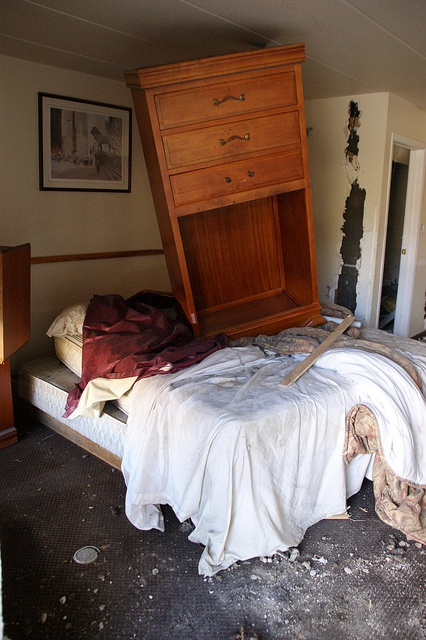Describe the objects in this image and their specific colors. I can see a bed in black, lightgray, darkgray, and maroon tones in this image. 